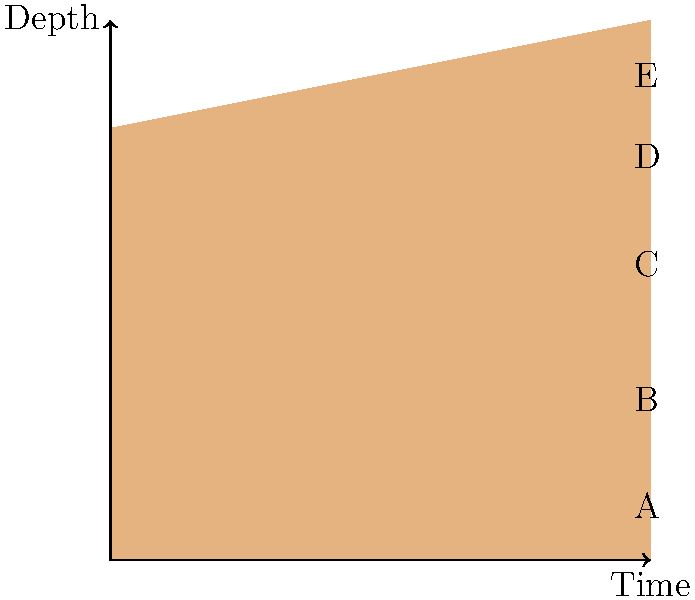Based on the stratigraphic cross-section provided, which layer is likely to contain the oldest artifacts, and how might this information impact our funding decisions for the excavation project? To answer this question, we need to understand the principle of superposition in stratigraphy and its implications for archaeological excavations. Let's break it down step-by-step:

1. Principle of Superposition: In undisturbed sedimentary layers, the oldest layers are at the bottom, and the youngest are at the top. This is because sediments are deposited over time, with newer layers forming on top of older ones.

2. Interpreting the diagram:
   - The x-axis represents time, and the y-axis represents depth.
   - There are five distinct layers labeled A through E from bottom to top.

3. Identifying the oldest layer:
   - Layer A is at the bottom of the sequence, making it the oldest layer.
   - As we move up the sequence, the layers become progressively younger (B, C, D, E).

4. Implications for artifacts:
   - The oldest artifacts are likely to be found in Layer A, as it represents the earliest period of deposition.

5. Impact on funding decisions:
   - As a representative from a cultural heritage organization, this information is crucial for allocating resources.
   - Layer A may contain the most historically significant artifacts, potentially representing the earliest human activity or occupation in the area.
   - Funding priority might be given to excavating and studying Layer A, as it could provide valuable insights into the earliest periods of the site's history.
   - However, it's important to note that all layers may contain important information, and a comprehensive excavation strategy should be considered.

6. Additional considerations:
   - The thickness of Layer C suggests a longer period of deposition or more rapid sedimentation, which might also be of interest for understanding the site's history and environmental changes.
   - The thin Layer D might represent a brief but significant period that warrants careful investigation.

In conclusion, while Layer A is likely to contain the oldest artifacts and may be a priority for funding, a balanced approach considering the potential significance of all layers would be advisable for a comprehensive understanding of the site's cultural heritage.
Answer: Layer A; prioritize funding for its excavation while considering all layers for comprehensive site understanding. 